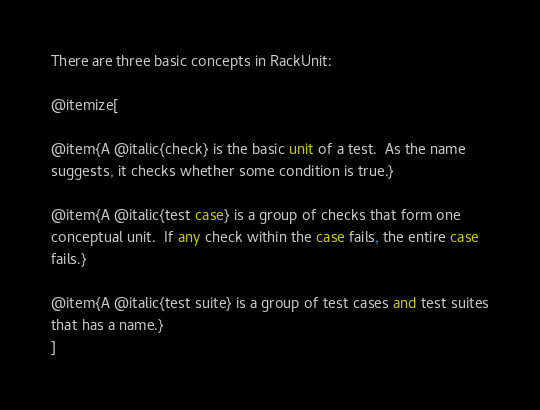Convert code to text. <code><loc_0><loc_0><loc_500><loc_500><_Racket_>
There are three basic concepts in RackUnit:

@itemize[

@item{A @italic{check} is the basic unit of a test.  As the name
suggests, it checks whether some condition is true.}

@item{A @italic{test case} is a group of checks that form one
conceptual unit.  If any check within the case fails, the entire case
fails.}

@item{A @italic{test suite} is a group of test cases and test suites
that has a name.}
]
</code> 